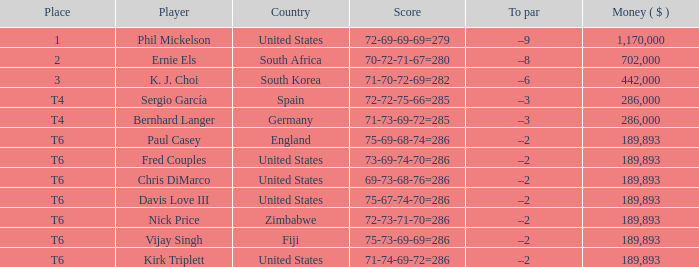What is the least money ($) when the country is united states and the player is kirk triplett? 189893.0. 